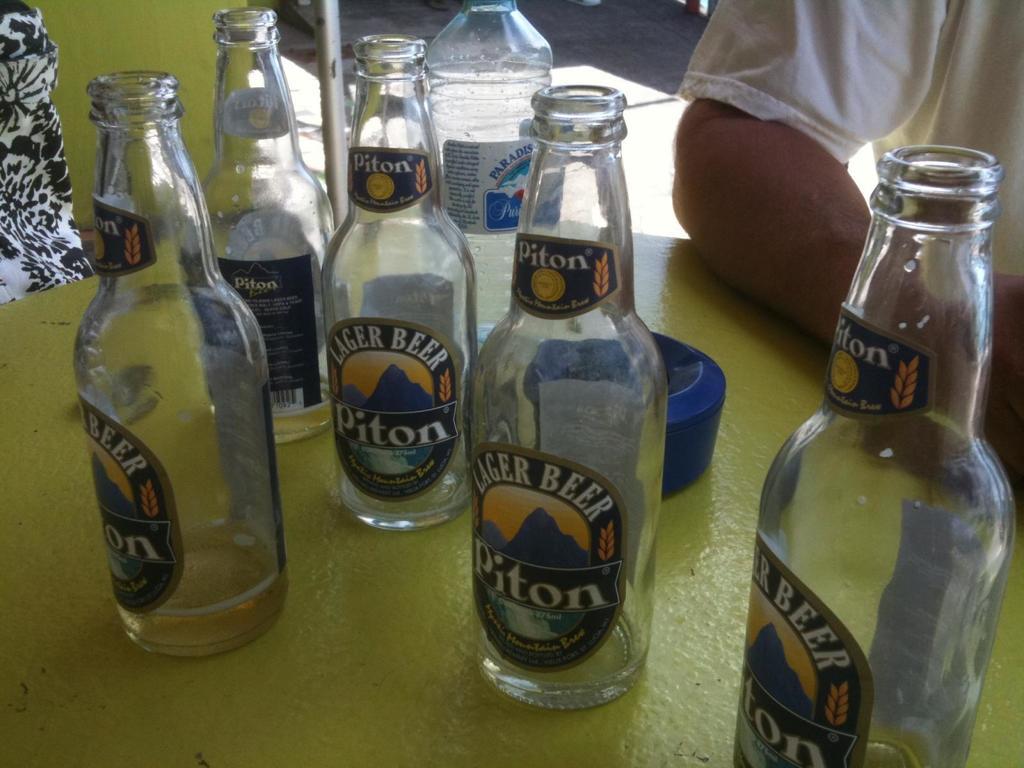What is the name of this beer?
Provide a short and direct response. Piton. Are the bottles empty?
Give a very brief answer. Answering does not require reading text in the image. 